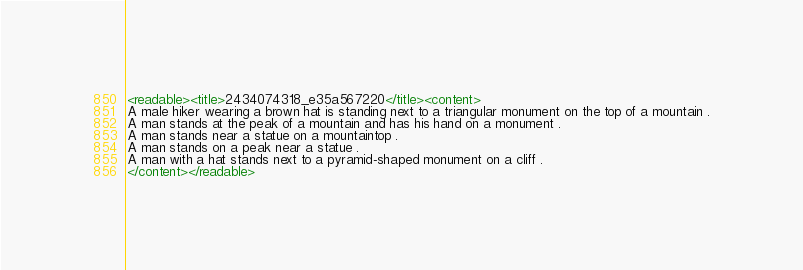<code> <loc_0><loc_0><loc_500><loc_500><_XML_><readable><title>2434074318_e35a567220</title><content>
A male hiker wearing a brown hat is standing next to a triangular monument on the top of a mountain .
A man stands at the peak of a mountain and has his hand on a monument .
A man stands near a statue on a mountaintop .
A man stands on a peak near a statue .
A man with a hat stands next to a pyramid-shaped monument on a cliff .
</content></readable></code> 